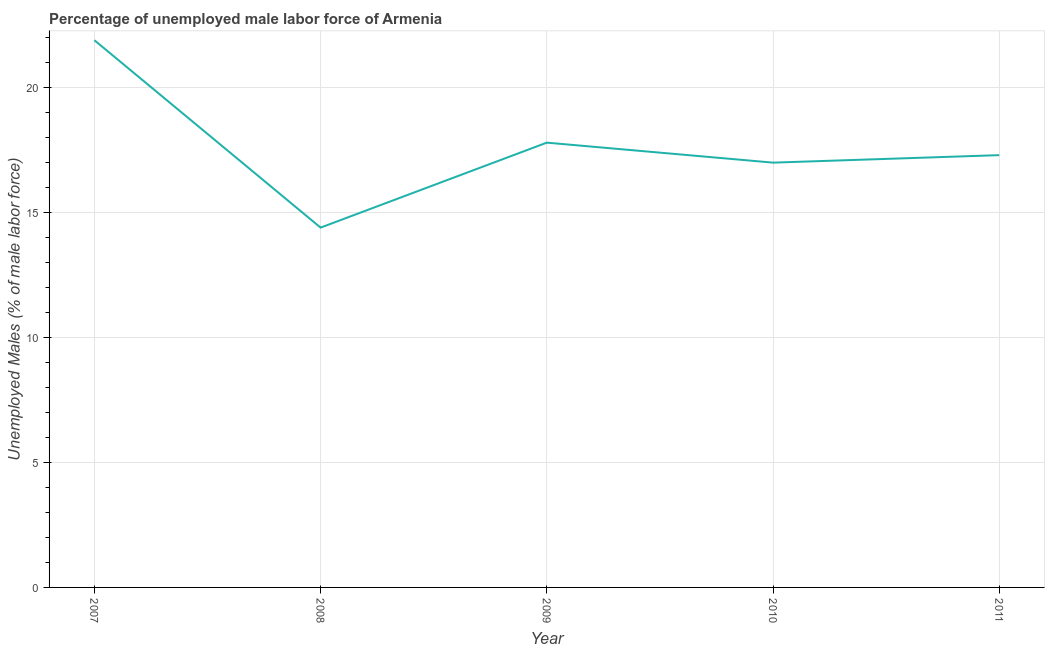What is the total unemployed male labour force in 2009?
Your answer should be compact. 17.8. Across all years, what is the maximum total unemployed male labour force?
Provide a short and direct response. 21.9. Across all years, what is the minimum total unemployed male labour force?
Offer a very short reply. 14.4. In which year was the total unemployed male labour force maximum?
Offer a terse response. 2007. In which year was the total unemployed male labour force minimum?
Provide a succinct answer. 2008. What is the sum of the total unemployed male labour force?
Your response must be concise. 88.4. What is the difference between the total unemployed male labour force in 2007 and 2011?
Your response must be concise. 4.6. What is the average total unemployed male labour force per year?
Provide a succinct answer. 17.68. What is the median total unemployed male labour force?
Your answer should be very brief. 17.3. In how many years, is the total unemployed male labour force greater than 18 %?
Your response must be concise. 1. What is the ratio of the total unemployed male labour force in 2007 to that in 2011?
Provide a short and direct response. 1.27. Is the total unemployed male labour force in 2008 less than that in 2009?
Your answer should be compact. Yes. What is the difference between the highest and the second highest total unemployed male labour force?
Make the answer very short. 4.1. What is the difference between the highest and the lowest total unemployed male labour force?
Keep it short and to the point. 7.5. In how many years, is the total unemployed male labour force greater than the average total unemployed male labour force taken over all years?
Make the answer very short. 2. Does the total unemployed male labour force monotonically increase over the years?
Your response must be concise. No. What is the difference between two consecutive major ticks on the Y-axis?
Make the answer very short. 5. What is the title of the graph?
Give a very brief answer. Percentage of unemployed male labor force of Armenia. What is the label or title of the Y-axis?
Provide a succinct answer. Unemployed Males (% of male labor force). What is the Unemployed Males (% of male labor force) of 2007?
Make the answer very short. 21.9. What is the Unemployed Males (% of male labor force) in 2008?
Offer a terse response. 14.4. What is the Unemployed Males (% of male labor force) in 2009?
Offer a very short reply. 17.8. What is the Unemployed Males (% of male labor force) in 2010?
Offer a very short reply. 17. What is the Unemployed Males (% of male labor force) of 2011?
Offer a terse response. 17.3. What is the difference between the Unemployed Males (% of male labor force) in 2007 and 2008?
Your response must be concise. 7.5. What is the difference between the Unemployed Males (% of male labor force) in 2007 and 2009?
Give a very brief answer. 4.1. What is the difference between the Unemployed Males (% of male labor force) in 2007 and 2010?
Your response must be concise. 4.9. What is the difference between the Unemployed Males (% of male labor force) in 2008 and 2009?
Offer a terse response. -3.4. What is the difference between the Unemployed Males (% of male labor force) in 2008 and 2010?
Offer a terse response. -2.6. What is the difference between the Unemployed Males (% of male labor force) in 2008 and 2011?
Ensure brevity in your answer.  -2.9. What is the ratio of the Unemployed Males (% of male labor force) in 2007 to that in 2008?
Your answer should be very brief. 1.52. What is the ratio of the Unemployed Males (% of male labor force) in 2007 to that in 2009?
Give a very brief answer. 1.23. What is the ratio of the Unemployed Males (% of male labor force) in 2007 to that in 2010?
Offer a terse response. 1.29. What is the ratio of the Unemployed Males (% of male labor force) in 2007 to that in 2011?
Offer a very short reply. 1.27. What is the ratio of the Unemployed Males (% of male labor force) in 2008 to that in 2009?
Offer a terse response. 0.81. What is the ratio of the Unemployed Males (% of male labor force) in 2008 to that in 2010?
Offer a very short reply. 0.85. What is the ratio of the Unemployed Males (% of male labor force) in 2008 to that in 2011?
Your response must be concise. 0.83. What is the ratio of the Unemployed Males (% of male labor force) in 2009 to that in 2010?
Make the answer very short. 1.05. 